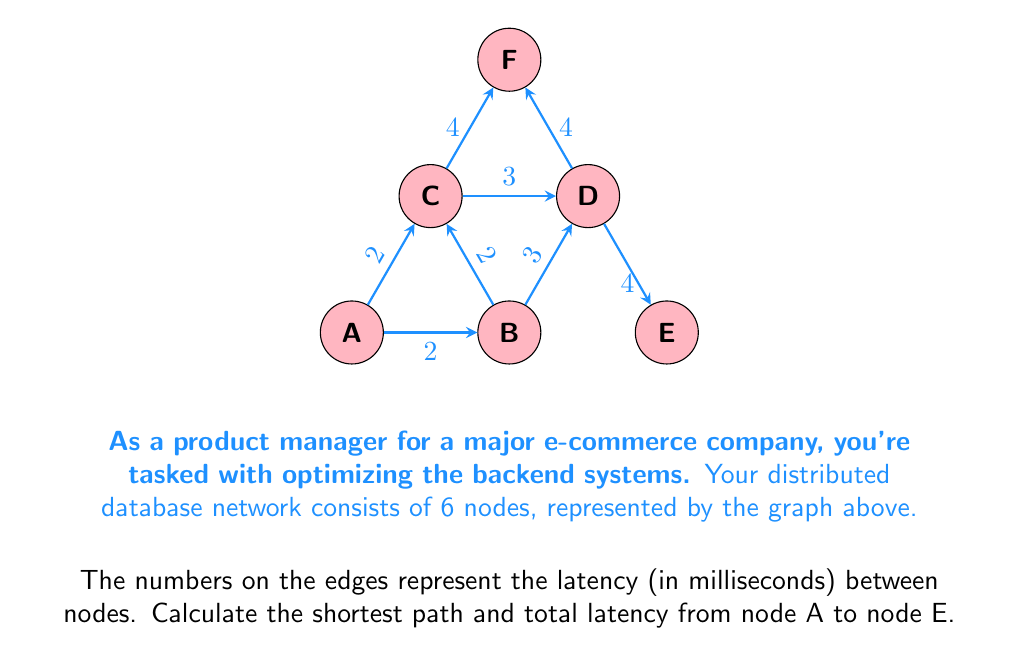Solve this math problem. To solve this problem, we can use Dijkstra's algorithm, which is an efficient method for finding the shortest path in a weighted graph. Let's follow the steps:

1) Initialize:
   - Set distance to A as 0
   - Set distances to all other nodes as infinity
   - Set all nodes as unvisited

2) Start from node A:
   - Update distances to neighbors:
     B: min(∞, 0 + 2) = 2
     C: min(∞, 0 + 2) = 2

3) Select the unvisited node with the smallest distance (B and C both have 2, let's choose B):
   - Update distances to B's neighbors:
     D: min(∞, 2 + 3) = 5

4) Select the next unvisited node with the smallest distance (C):
   - Update distances to C's neighbors:
     D: min(5, 2 + 3) = 5 (no change)
     F: min(∞, 2 + 4) = 6

5) Select the next unvisited node with the smallest distance (D):
   - Update distances to D's neighbors:
     E: min(∞, 5 + 4) = 9
     F: min(6, 5 + 4) = 6 (no change)

6) We've reached node E, so we can stop here.

The shortest path from A to E is A → B → D → E with a total latency of 9 ms.
Answer: Path: A → B → D → E; Total latency: 9 ms 